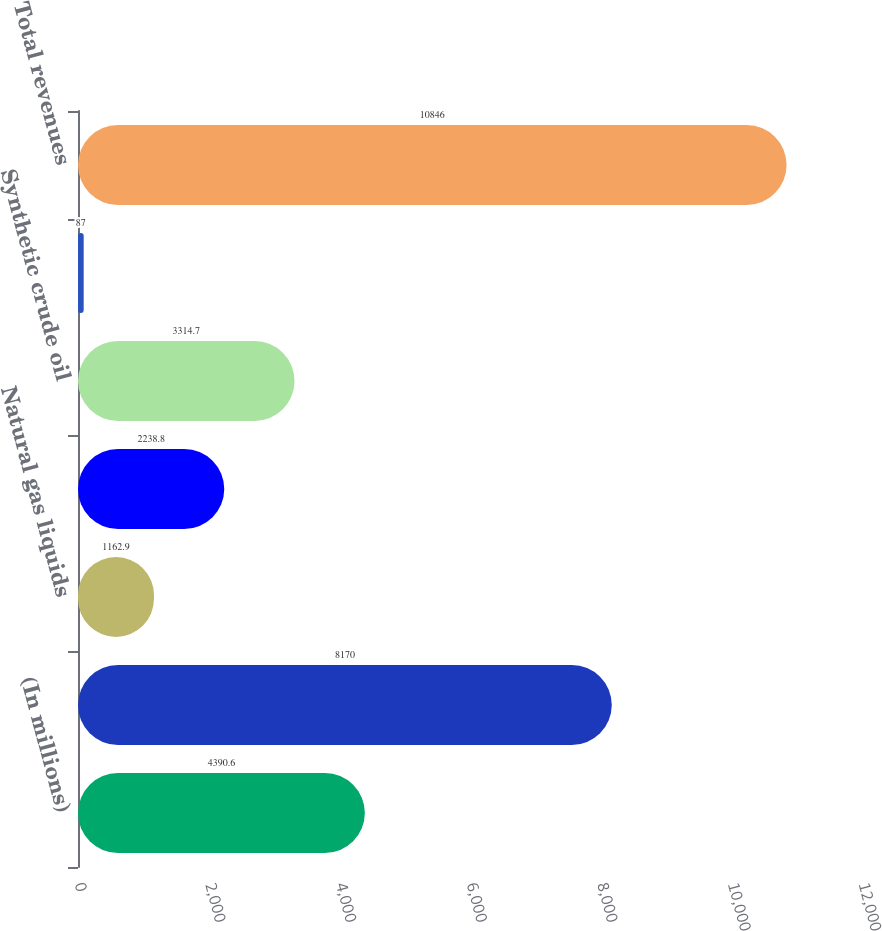<chart> <loc_0><loc_0><loc_500><loc_500><bar_chart><fcel>(In millions)<fcel>Crude oil and condensate<fcel>Natural gas liquids<fcel>Natural gas<fcel>Synthetic crude oil<fcel>Other<fcel>Total revenues<nl><fcel>4390.6<fcel>8170<fcel>1162.9<fcel>2238.8<fcel>3314.7<fcel>87<fcel>10846<nl></chart> 